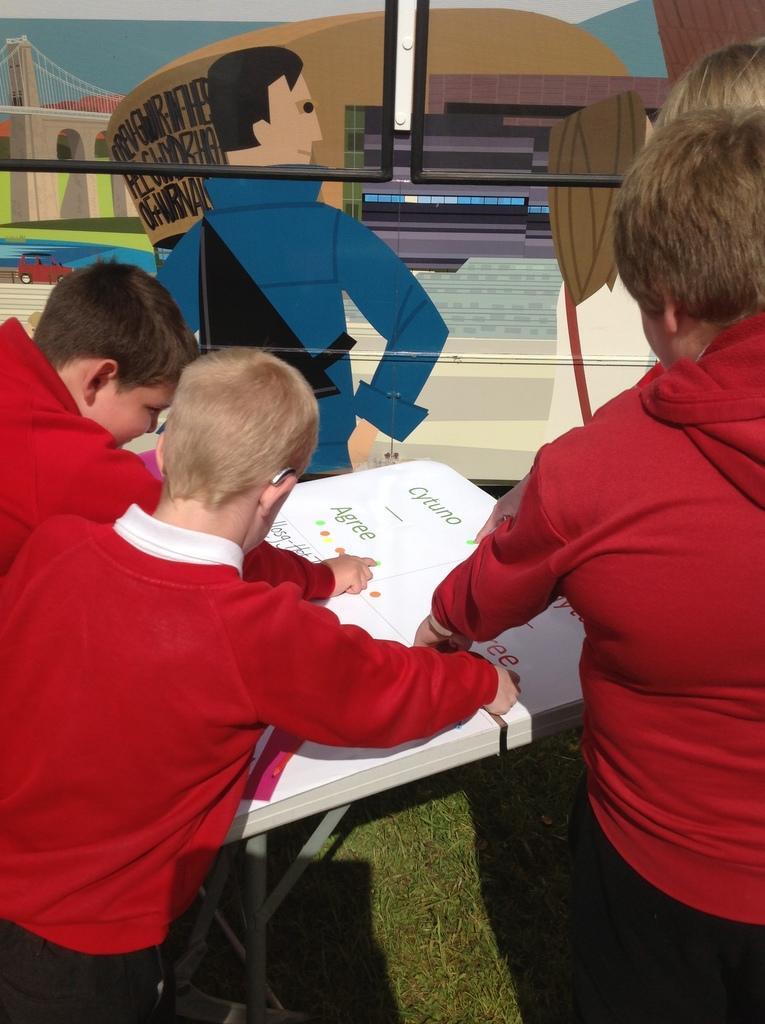In one or two sentences, can you explain what this image depicts? In this image, I can see three boys standing. This is a table. I can see the painting of the cartoon images on an object. At the bottom of the image, I can see the grass. 